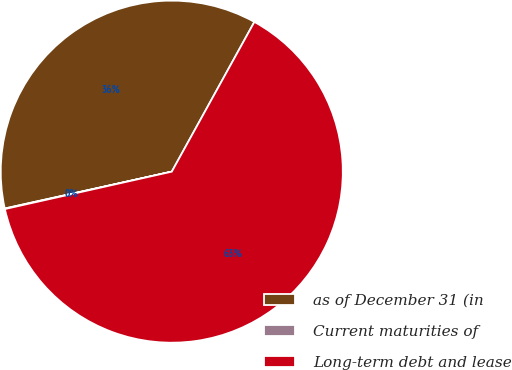Convert chart. <chart><loc_0><loc_0><loc_500><loc_500><pie_chart><fcel>as of December 31 (in<fcel>Current maturities of<fcel>Long-term debt and lease<nl><fcel>36.48%<fcel>0.05%<fcel>63.47%<nl></chart> 